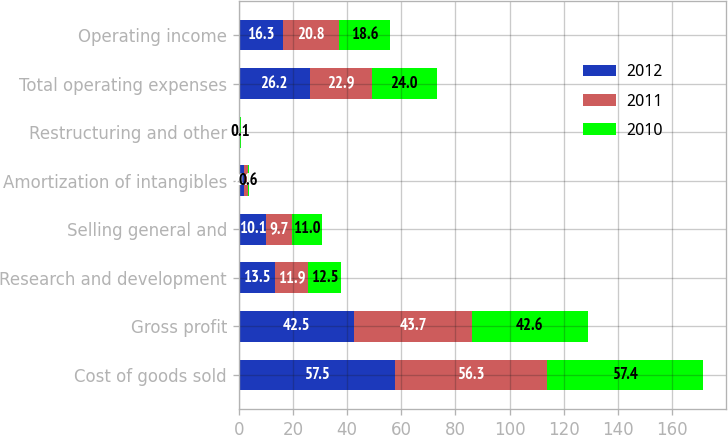Convert chart. <chart><loc_0><loc_0><loc_500><loc_500><stacked_bar_chart><ecel><fcel>Cost of goods sold<fcel>Gross profit<fcel>Research and development<fcel>Selling general and<fcel>Amortization of intangibles<fcel>Restructuring and other<fcel>Total operating expenses<fcel>Operating income<nl><fcel>2012<fcel>57.5<fcel>42.5<fcel>13.5<fcel>10.1<fcel>2.1<fcel>0.5<fcel>26.2<fcel>16.3<nl><fcel>2011<fcel>56.3<fcel>43.7<fcel>11.9<fcel>9.7<fcel>1.2<fcel>0.1<fcel>22.9<fcel>20.8<nl><fcel>2010<fcel>57.4<fcel>42.6<fcel>12.5<fcel>11<fcel>0.6<fcel>0.1<fcel>24<fcel>18.6<nl></chart> 